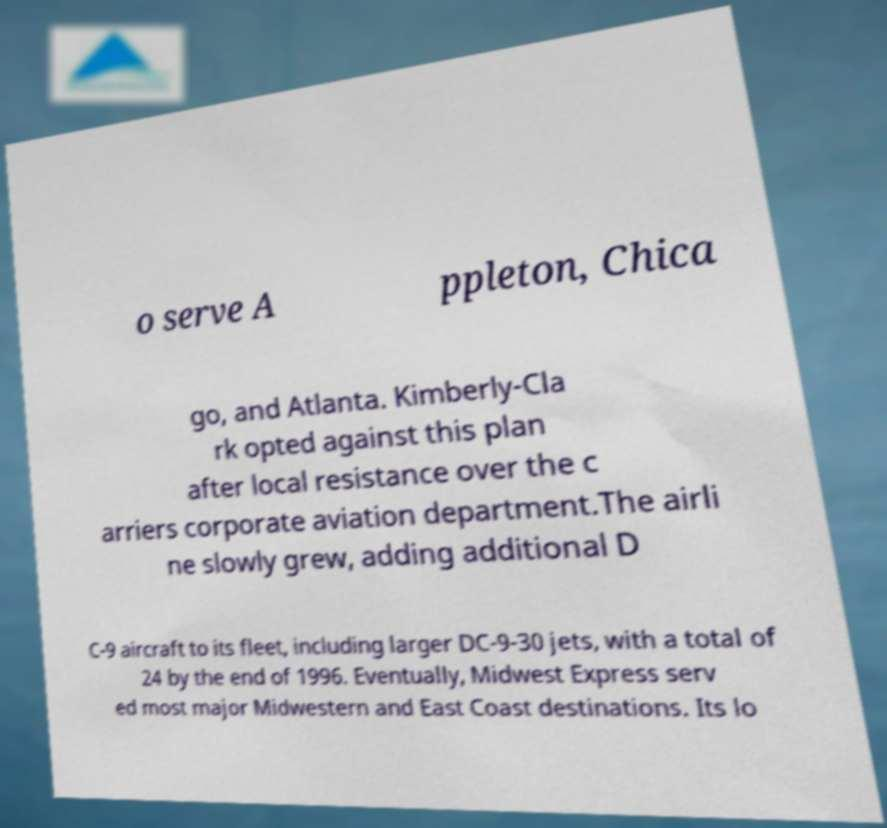What messages or text are displayed in this image? I need them in a readable, typed format. o serve A ppleton, Chica go, and Atlanta. Kimberly-Cla rk opted against this plan after local resistance over the c arriers corporate aviation department.The airli ne slowly grew, adding additional D C-9 aircraft to its fleet, including larger DC-9-30 jets, with a total of 24 by the end of 1996. Eventually, Midwest Express serv ed most major Midwestern and East Coast destinations. Its lo 